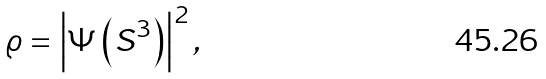Convert formula to latex. <formula><loc_0><loc_0><loc_500><loc_500>\varrho = \left | \Psi \left ( S ^ { 3 } \right ) \right | ^ { 2 } ,</formula> 